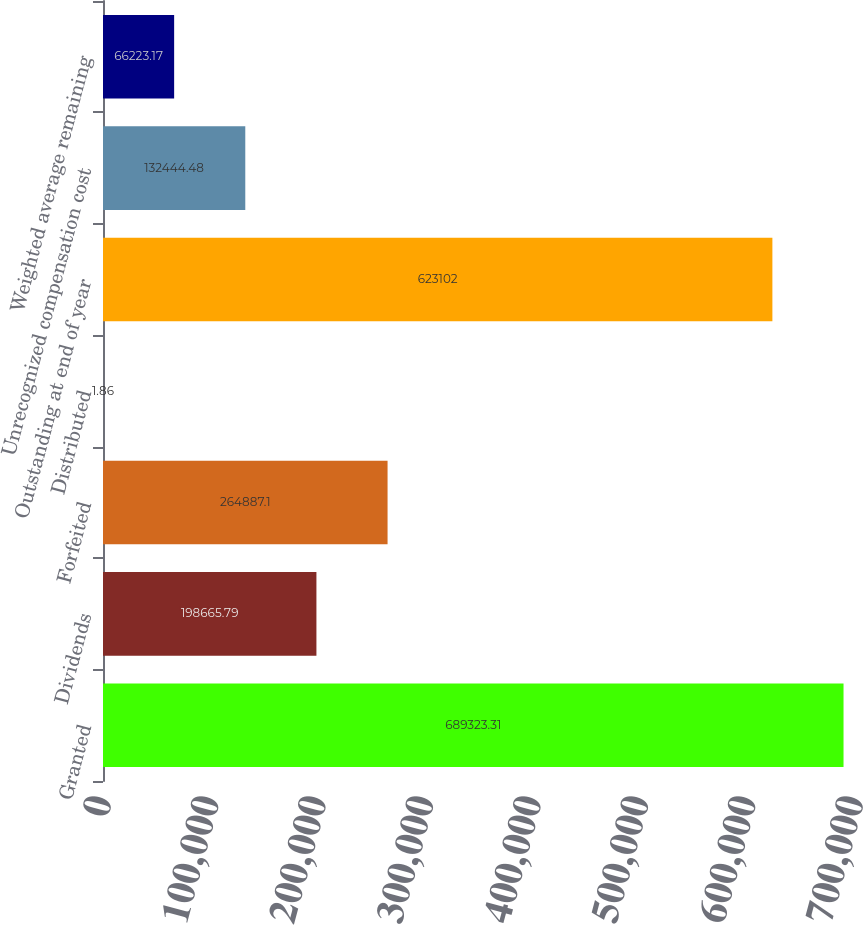Convert chart. <chart><loc_0><loc_0><loc_500><loc_500><bar_chart><fcel>Granted<fcel>Dividends<fcel>Forfeited<fcel>Distributed<fcel>Outstanding at end of year<fcel>Unrecognized compensation cost<fcel>Weighted average remaining<nl><fcel>689323<fcel>198666<fcel>264887<fcel>1.86<fcel>623102<fcel>132444<fcel>66223.2<nl></chart> 